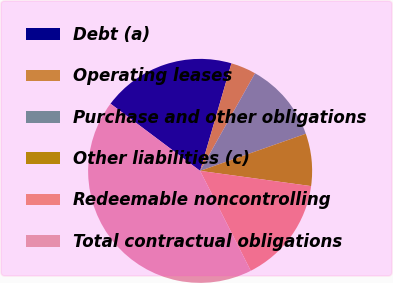Convert chart to OTSL. <chart><loc_0><loc_0><loc_500><loc_500><pie_chart><fcel>Debt (a)<fcel>Operating leases<fcel>Purchase and other obligations<fcel>Other liabilities (c)<fcel>Redeemable noncontrolling<fcel>Total contractual obligations<nl><fcel>19.27%<fcel>3.65%<fcel>11.46%<fcel>7.55%<fcel>15.36%<fcel>42.7%<nl></chart> 